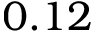Convert formula to latex. <formula><loc_0><loc_0><loc_500><loc_500>0 . 1 2</formula> 